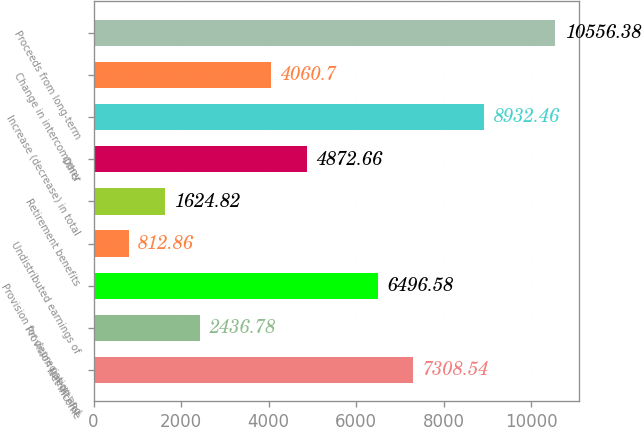<chart> <loc_0><loc_0><loc_500><loc_500><bar_chart><fcel>Net income<fcel>Provision (credit) for<fcel>Provision for depreciation and<fcel>Undistributed earnings of<fcel>Retirement benefits<fcel>Other<fcel>Increase (decrease) in total<fcel>Change in intercompany<fcel>Proceeds from long-term<nl><fcel>7308.54<fcel>2436.78<fcel>6496.58<fcel>812.86<fcel>1624.82<fcel>4872.66<fcel>8932.46<fcel>4060.7<fcel>10556.4<nl></chart> 